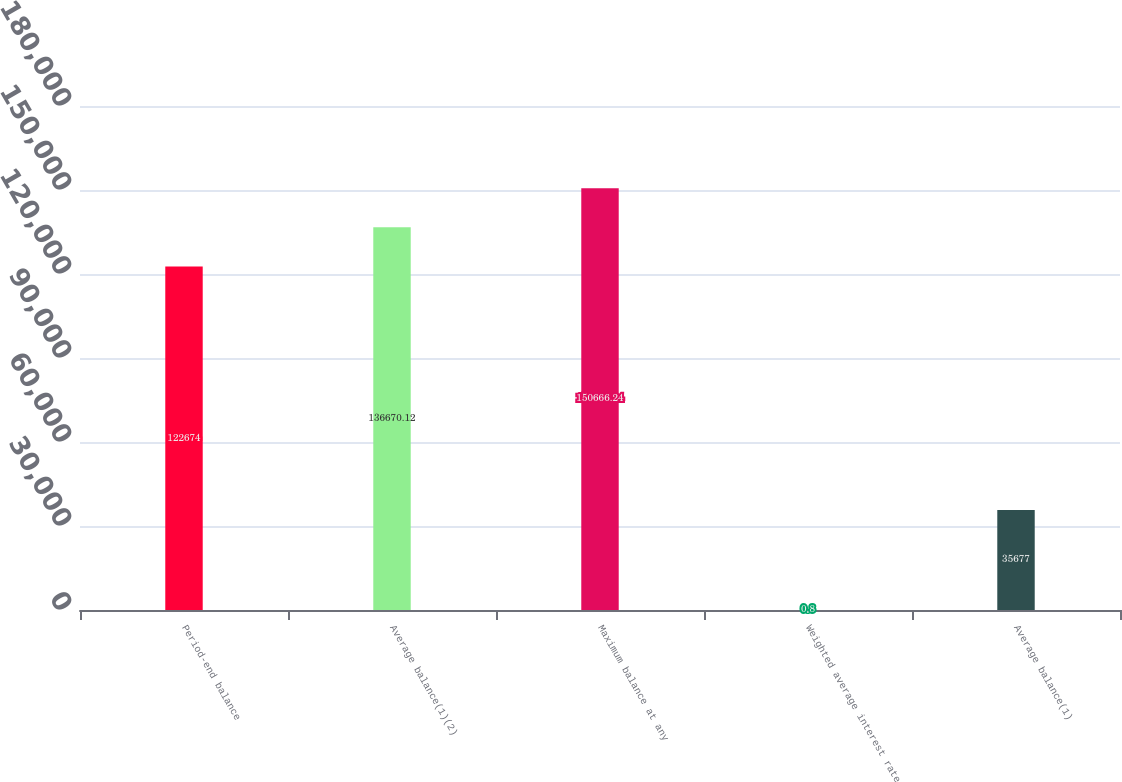Convert chart. <chart><loc_0><loc_0><loc_500><loc_500><bar_chart><fcel>Period-end balance<fcel>Average balance(1)(2)<fcel>Maximum balance at any<fcel>Weighted average interest rate<fcel>Average balance(1)<nl><fcel>122674<fcel>136670<fcel>150666<fcel>0.8<fcel>35677<nl></chart> 